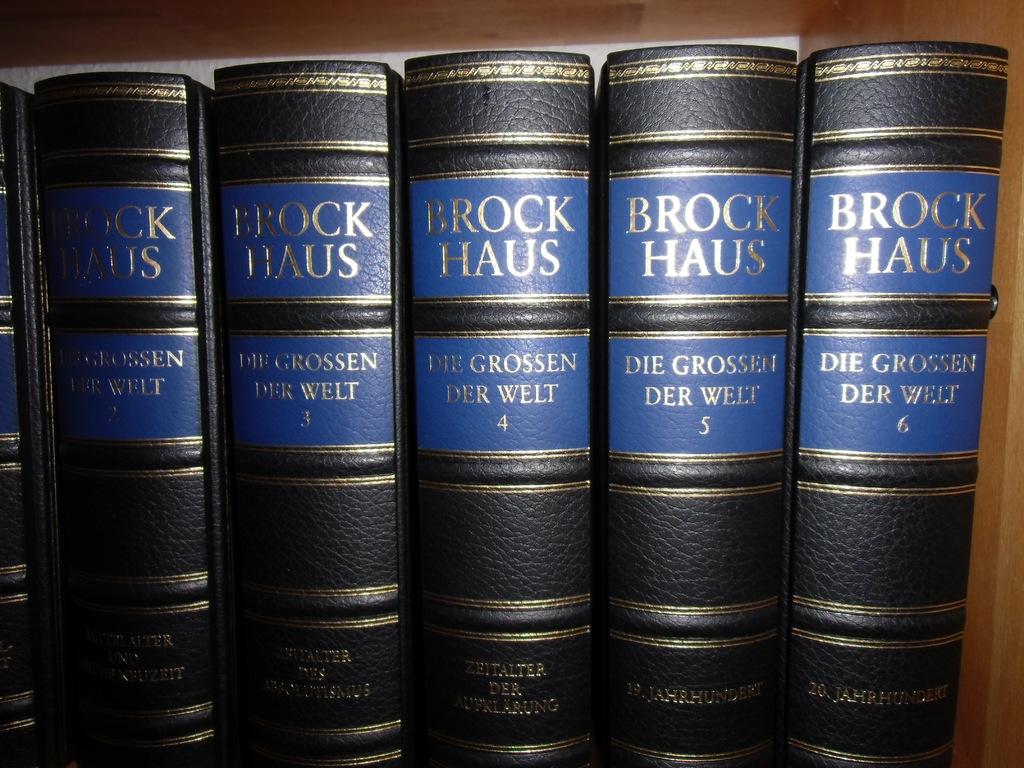What is the title of the books?
Provide a succinct answer. Die grossen der welt. 